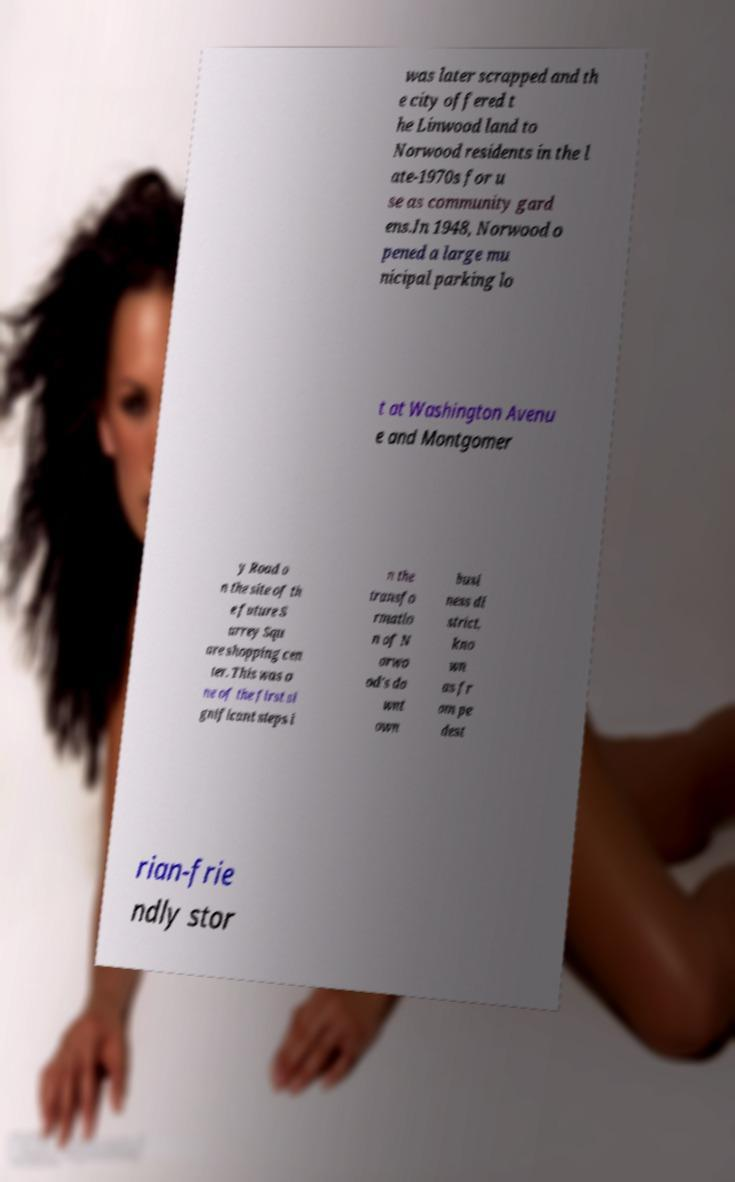Could you assist in decoding the text presented in this image and type it out clearly? was later scrapped and th e city offered t he Linwood land to Norwood residents in the l ate-1970s for u se as community gard ens.In 1948, Norwood o pened a large mu nicipal parking lo t at Washington Avenu e and Montgomer y Road o n the site of th e future S urrey Squ are shopping cen ter. This was o ne of the first si gnificant steps i n the transfo rmatio n of N orwo od's do wnt own busi ness di strict, kno wn as fr om pe dest rian-frie ndly stor 